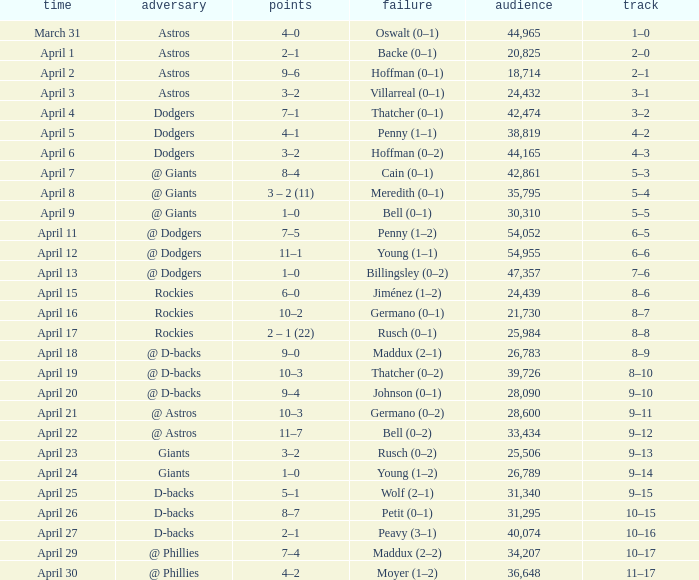What was the score on April 21? 10–3. 